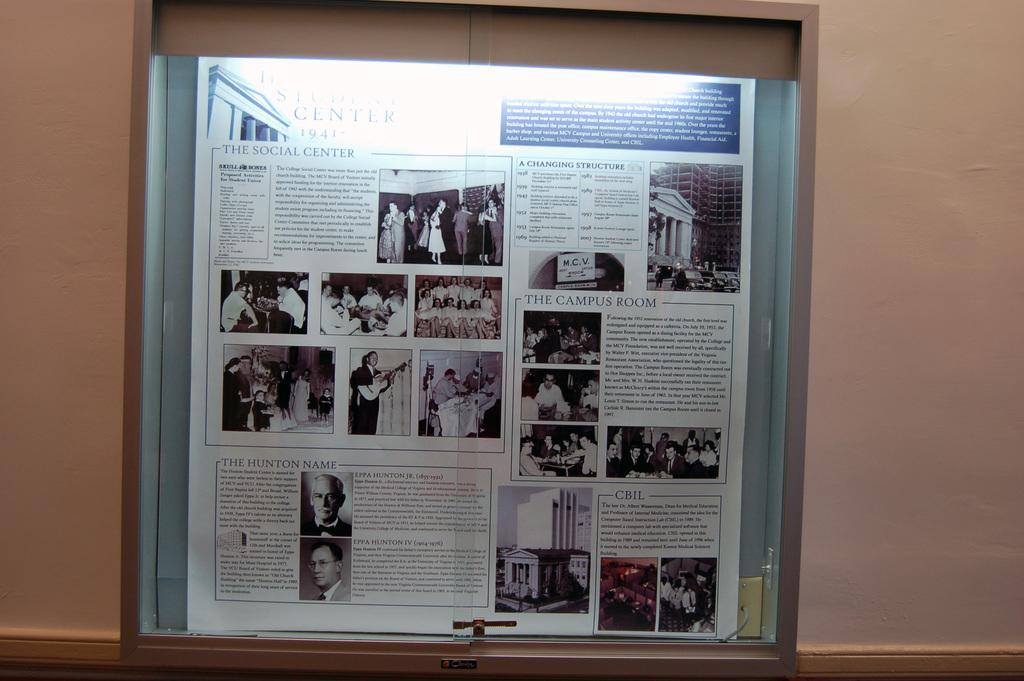Describe this image in one or two sentences. In this image there are paper clippings in a notice board, the board is on the wall. 